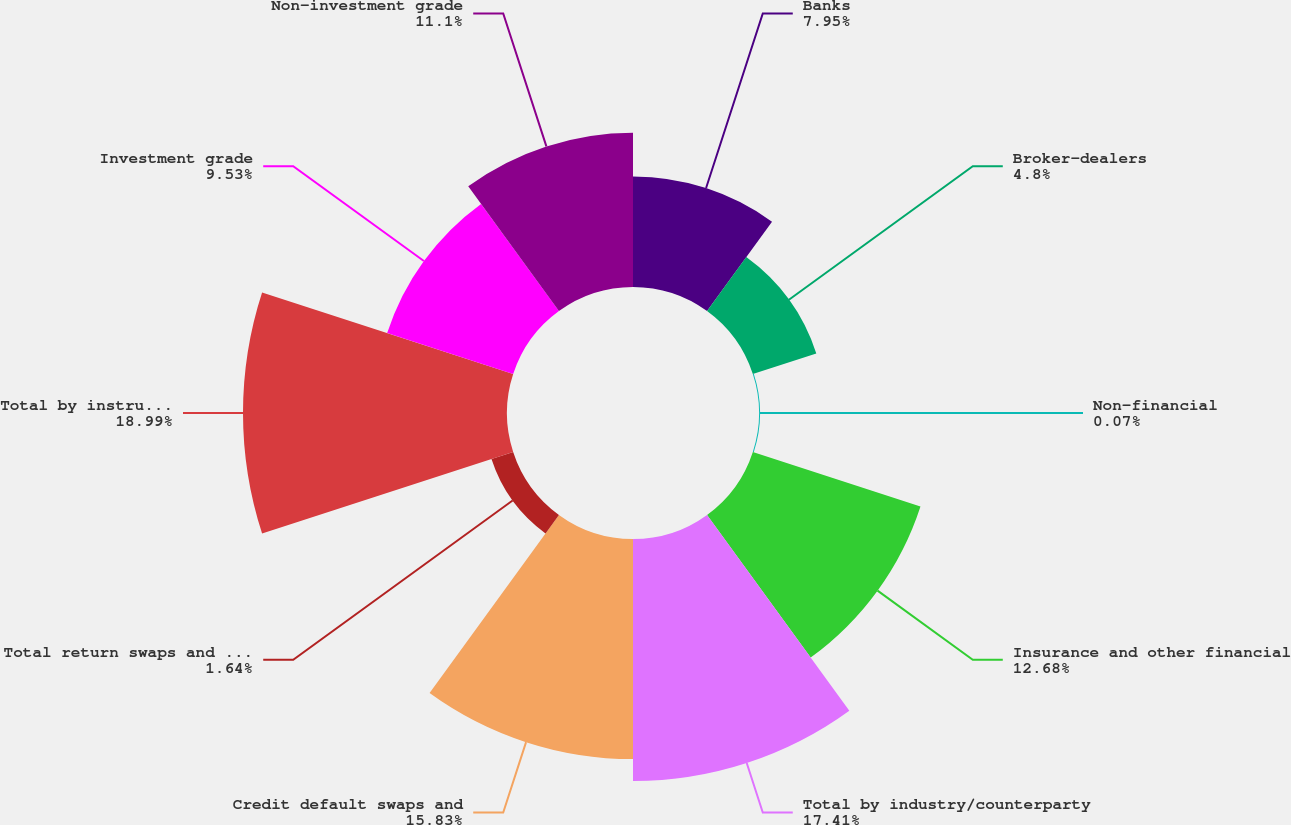<chart> <loc_0><loc_0><loc_500><loc_500><pie_chart><fcel>Banks<fcel>Broker-dealers<fcel>Non-financial<fcel>Insurance and other financial<fcel>Total by industry/counterparty<fcel>Credit default swaps and<fcel>Total return swaps and other<fcel>Total by instrument<fcel>Investment grade<fcel>Non-investment grade<nl><fcel>7.95%<fcel>4.8%<fcel>0.07%<fcel>12.68%<fcel>17.41%<fcel>15.83%<fcel>1.64%<fcel>18.99%<fcel>9.53%<fcel>11.1%<nl></chart> 